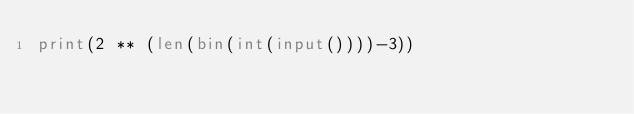Convert code to text. <code><loc_0><loc_0><loc_500><loc_500><_Python_>print(2 ** (len(bin(int(input())))-3))
</code> 